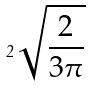Convert formula to latex. <formula><loc_0><loc_0><loc_500><loc_500>2 \sqrt { \frac { 2 } { 3 \pi } }</formula> 